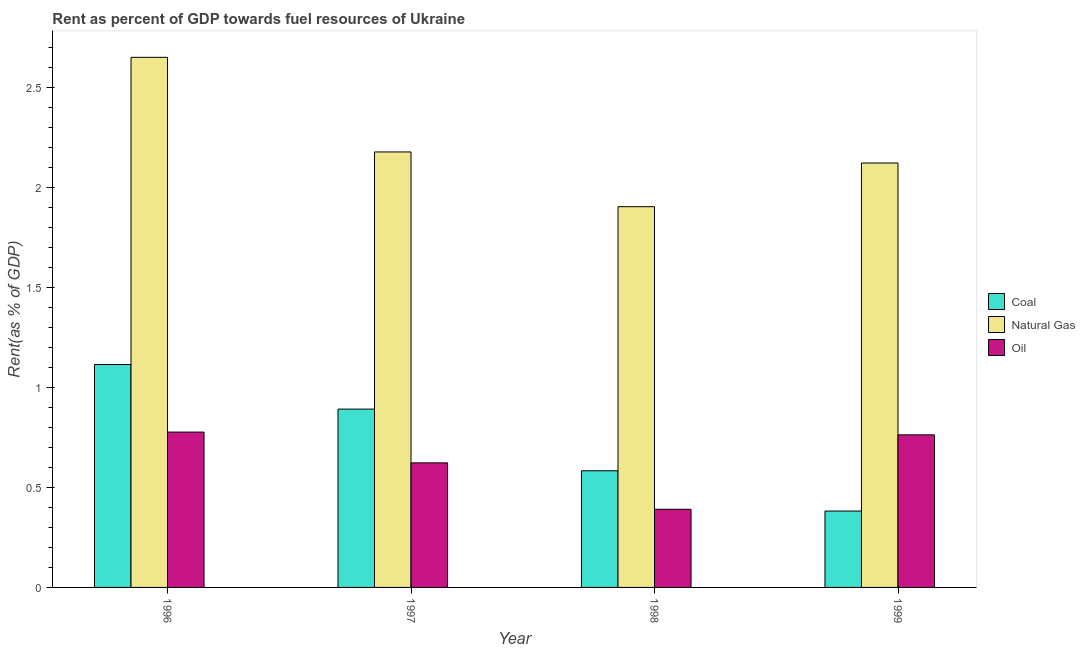Are the number of bars per tick equal to the number of legend labels?
Your answer should be very brief. Yes. How many bars are there on the 1st tick from the left?
Ensure brevity in your answer.  3. How many bars are there on the 2nd tick from the right?
Offer a terse response. 3. What is the rent towards natural gas in 1998?
Offer a terse response. 1.91. Across all years, what is the maximum rent towards oil?
Your response must be concise. 0.78. Across all years, what is the minimum rent towards natural gas?
Provide a succinct answer. 1.91. What is the total rent towards coal in the graph?
Your answer should be compact. 2.97. What is the difference between the rent towards natural gas in 1996 and that in 1999?
Provide a short and direct response. 0.53. What is the difference between the rent towards natural gas in 1997 and the rent towards coal in 1998?
Your answer should be very brief. 0.27. What is the average rent towards natural gas per year?
Offer a terse response. 2.22. In the year 1998, what is the difference between the rent towards coal and rent towards oil?
Ensure brevity in your answer.  0. In how many years, is the rent towards oil greater than 1 %?
Offer a very short reply. 0. What is the ratio of the rent towards coal in 1997 to that in 1998?
Keep it short and to the point. 1.53. Is the rent towards oil in 1997 less than that in 1998?
Provide a succinct answer. No. What is the difference between the highest and the second highest rent towards oil?
Offer a terse response. 0.01. What is the difference between the highest and the lowest rent towards oil?
Give a very brief answer. 0.39. What does the 2nd bar from the left in 1999 represents?
Provide a succinct answer. Natural Gas. What does the 1st bar from the right in 1998 represents?
Provide a succinct answer. Oil. How many bars are there?
Keep it short and to the point. 12. What is the difference between two consecutive major ticks on the Y-axis?
Provide a succinct answer. 0.5. Where does the legend appear in the graph?
Offer a very short reply. Center right. What is the title of the graph?
Your answer should be very brief. Rent as percent of GDP towards fuel resources of Ukraine. Does "Ages 20-50" appear as one of the legend labels in the graph?
Make the answer very short. No. What is the label or title of the Y-axis?
Provide a short and direct response. Rent(as % of GDP). What is the Rent(as % of GDP) of Coal in 1996?
Your response must be concise. 1.12. What is the Rent(as % of GDP) of Natural Gas in 1996?
Offer a terse response. 2.65. What is the Rent(as % of GDP) in Oil in 1996?
Ensure brevity in your answer.  0.78. What is the Rent(as % of GDP) of Coal in 1997?
Your answer should be very brief. 0.89. What is the Rent(as % of GDP) of Natural Gas in 1997?
Provide a short and direct response. 2.18. What is the Rent(as % of GDP) in Oil in 1997?
Provide a short and direct response. 0.62. What is the Rent(as % of GDP) in Coal in 1998?
Offer a terse response. 0.58. What is the Rent(as % of GDP) of Natural Gas in 1998?
Give a very brief answer. 1.91. What is the Rent(as % of GDP) in Oil in 1998?
Your answer should be compact. 0.39. What is the Rent(as % of GDP) in Coal in 1999?
Offer a very short reply. 0.38. What is the Rent(as % of GDP) in Natural Gas in 1999?
Your answer should be compact. 2.12. What is the Rent(as % of GDP) in Oil in 1999?
Your answer should be compact. 0.76. Across all years, what is the maximum Rent(as % of GDP) of Coal?
Your response must be concise. 1.12. Across all years, what is the maximum Rent(as % of GDP) in Natural Gas?
Provide a succinct answer. 2.65. Across all years, what is the maximum Rent(as % of GDP) in Oil?
Offer a very short reply. 0.78. Across all years, what is the minimum Rent(as % of GDP) of Coal?
Keep it short and to the point. 0.38. Across all years, what is the minimum Rent(as % of GDP) in Natural Gas?
Provide a succinct answer. 1.91. Across all years, what is the minimum Rent(as % of GDP) of Oil?
Ensure brevity in your answer.  0.39. What is the total Rent(as % of GDP) of Coal in the graph?
Offer a terse response. 2.97. What is the total Rent(as % of GDP) in Natural Gas in the graph?
Give a very brief answer. 8.86. What is the total Rent(as % of GDP) of Oil in the graph?
Ensure brevity in your answer.  2.56. What is the difference between the Rent(as % of GDP) of Coal in 1996 and that in 1997?
Give a very brief answer. 0.22. What is the difference between the Rent(as % of GDP) of Natural Gas in 1996 and that in 1997?
Your answer should be very brief. 0.47. What is the difference between the Rent(as % of GDP) in Oil in 1996 and that in 1997?
Make the answer very short. 0.15. What is the difference between the Rent(as % of GDP) of Coal in 1996 and that in 1998?
Your answer should be compact. 0.53. What is the difference between the Rent(as % of GDP) in Natural Gas in 1996 and that in 1998?
Ensure brevity in your answer.  0.75. What is the difference between the Rent(as % of GDP) of Oil in 1996 and that in 1998?
Make the answer very short. 0.39. What is the difference between the Rent(as % of GDP) in Coal in 1996 and that in 1999?
Give a very brief answer. 0.73. What is the difference between the Rent(as % of GDP) of Natural Gas in 1996 and that in 1999?
Make the answer very short. 0.53. What is the difference between the Rent(as % of GDP) of Oil in 1996 and that in 1999?
Your response must be concise. 0.01. What is the difference between the Rent(as % of GDP) of Coal in 1997 and that in 1998?
Your response must be concise. 0.31. What is the difference between the Rent(as % of GDP) of Natural Gas in 1997 and that in 1998?
Provide a short and direct response. 0.27. What is the difference between the Rent(as % of GDP) of Oil in 1997 and that in 1998?
Offer a terse response. 0.23. What is the difference between the Rent(as % of GDP) of Coal in 1997 and that in 1999?
Offer a terse response. 0.51. What is the difference between the Rent(as % of GDP) of Natural Gas in 1997 and that in 1999?
Make the answer very short. 0.06. What is the difference between the Rent(as % of GDP) of Oil in 1997 and that in 1999?
Make the answer very short. -0.14. What is the difference between the Rent(as % of GDP) in Coal in 1998 and that in 1999?
Your response must be concise. 0.2. What is the difference between the Rent(as % of GDP) of Natural Gas in 1998 and that in 1999?
Make the answer very short. -0.22. What is the difference between the Rent(as % of GDP) in Oil in 1998 and that in 1999?
Your response must be concise. -0.37. What is the difference between the Rent(as % of GDP) of Coal in 1996 and the Rent(as % of GDP) of Natural Gas in 1997?
Provide a succinct answer. -1.06. What is the difference between the Rent(as % of GDP) of Coal in 1996 and the Rent(as % of GDP) of Oil in 1997?
Ensure brevity in your answer.  0.49. What is the difference between the Rent(as % of GDP) of Natural Gas in 1996 and the Rent(as % of GDP) of Oil in 1997?
Provide a short and direct response. 2.03. What is the difference between the Rent(as % of GDP) in Coal in 1996 and the Rent(as % of GDP) in Natural Gas in 1998?
Ensure brevity in your answer.  -0.79. What is the difference between the Rent(as % of GDP) in Coal in 1996 and the Rent(as % of GDP) in Oil in 1998?
Keep it short and to the point. 0.72. What is the difference between the Rent(as % of GDP) of Natural Gas in 1996 and the Rent(as % of GDP) of Oil in 1998?
Your answer should be very brief. 2.26. What is the difference between the Rent(as % of GDP) of Coal in 1996 and the Rent(as % of GDP) of Natural Gas in 1999?
Offer a very short reply. -1.01. What is the difference between the Rent(as % of GDP) in Coal in 1996 and the Rent(as % of GDP) in Oil in 1999?
Offer a terse response. 0.35. What is the difference between the Rent(as % of GDP) in Natural Gas in 1996 and the Rent(as % of GDP) in Oil in 1999?
Ensure brevity in your answer.  1.89. What is the difference between the Rent(as % of GDP) in Coal in 1997 and the Rent(as % of GDP) in Natural Gas in 1998?
Your answer should be very brief. -1.01. What is the difference between the Rent(as % of GDP) of Coal in 1997 and the Rent(as % of GDP) of Oil in 1998?
Give a very brief answer. 0.5. What is the difference between the Rent(as % of GDP) in Natural Gas in 1997 and the Rent(as % of GDP) in Oil in 1998?
Make the answer very short. 1.79. What is the difference between the Rent(as % of GDP) of Coal in 1997 and the Rent(as % of GDP) of Natural Gas in 1999?
Ensure brevity in your answer.  -1.23. What is the difference between the Rent(as % of GDP) of Coal in 1997 and the Rent(as % of GDP) of Oil in 1999?
Provide a short and direct response. 0.13. What is the difference between the Rent(as % of GDP) in Natural Gas in 1997 and the Rent(as % of GDP) in Oil in 1999?
Provide a short and direct response. 1.42. What is the difference between the Rent(as % of GDP) in Coal in 1998 and the Rent(as % of GDP) in Natural Gas in 1999?
Your answer should be very brief. -1.54. What is the difference between the Rent(as % of GDP) in Coal in 1998 and the Rent(as % of GDP) in Oil in 1999?
Your answer should be compact. -0.18. What is the difference between the Rent(as % of GDP) in Natural Gas in 1998 and the Rent(as % of GDP) in Oil in 1999?
Ensure brevity in your answer.  1.14. What is the average Rent(as % of GDP) in Coal per year?
Offer a very short reply. 0.74. What is the average Rent(as % of GDP) in Natural Gas per year?
Provide a short and direct response. 2.22. What is the average Rent(as % of GDP) in Oil per year?
Your answer should be compact. 0.64. In the year 1996, what is the difference between the Rent(as % of GDP) in Coal and Rent(as % of GDP) in Natural Gas?
Offer a terse response. -1.54. In the year 1996, what is the difference between the Rent(as % of GDP) in Coal and Rent(as % of GDP) in Oil?
Give a very brief answer. 0.34. In the year 1996, what is the difference between the Rent(as % of GDP) in Natural Gas and Rent(as % of GDP) in Oil?
Provide a succinct answer. 1.88. In the year 1997, what is the difference between the Rent(as % of GDP) in Coal and Rent(as % of GDP) in Natural Gas?
Keep it short and to the point. -1.29. In the year 1997, what is the difference between the Rent(as % of GDP) of Coal and Rent(as % of GDP) of Oil?
Offer a terse response. 0.27. In the year 1997, what is the difference between the Rent(as % of GDP) in Natural Gas and Rent(as % of GDP) in Oil?
Provide a succinct answer. 1.56. In the year 1998, what is the difference between the Rent(as % of GDP) in Coal and Rent(as % of GDP) in Natural Gas?
Your answer should be compact. -1.32. In the year 1998, what is the difference between the Rent(as % of GDP) in Coal and Rent(as % of GDP) in Oil?
Keep it short and to the point. 0.19. In the year 1998, what is the difference between the Rent(as % of GDP) of Natural Gas and Rent(as % of GDP) of Oil?
Offer a very short reply. 1.51. In the year 1999, what is the difference between the Rent(as % of GDP) of Coal and Rent(as % of GDP) of Natural Gas?
Your answer should be compact. -1.74. In the year 1999, what is the difference between the Rent(as % of GDP) of Coal and Rent(as % of GDP) of Oil?
Ensure brevity in your answer.  -0.38. In the year 1999, what is the difference between the Rent(as % of GDP) of Natural Gas and Rent(as % of GDP) of Oil?
Your response must be concise. 1.36. What is the ratio of the Rent(as % of GDP) of Natural Gas in 1996 to that in 1997?
Offer a very short reply. 1.22. What is the ratio of the Rent(as % of GDP) of Oil in 1996 to that in 1997?
Your answer should be very brief. 1.25. What is the ratio of the Rent(as % of GDP) in Coal in 1996 to that in 1998?
Your response must be concise. 1.91. What is the ratio of the Rent(as % of GDP) in Natural Gas in 1996 to that in 1998?
Your answer should be very brief. 1.39. What is the ratio of the Rent(as % of GDP) of Oil in 1996 to that in 1998?
Offer a very short reply. 1.99. What is the ratio of the Rent(as % of GDP) in Coal in 1996 to that in 1999?
Keep it short and to the point. 2.92. What is the ratio of the Rent(as % of GDP) in Natural Gas in 1996 to that in 1999?
Provide a short and direct response. 1.25. What is the ratio of the Rent(as % of GDP) of Oil in 1996 to that in 1999?
Provide a short and direct response. 1.02. What is the ratio of the Rent(as % of GDP) in Coal in 1997 to that in 1998?
Ensure brevity in your answer.  1.53. What is the ratio of the Rent(as % of GDP) of Natural Gas in 1997 to that in 1998?
Provide a short and direct response. 1.14. What is the ratio of the Rent(as % of GDP) of Oil in 1997 to that in 1998?
Ensure brevity in your answer.  1.59. What is the ratio of the Rent(as % of GDP) in Coal in 1997 to that in 1999?
Offer a terse response. 2.33. What is the ratio of the Rent(as % of GDP) in Oil in 1997 to that in 1999?
Give a very brief answer. 0.82. What is the ratio of the Rent(as % of GDP) of Coal in 1998 to that in 1999?
Make the answer very short. 1.53. What is the ratio of the Rent(as % of GDP) in Natural Gas in 1998 to that in 1999?
Provide a succinct answer. 0.9. What is the ratio of the Rent(as % of GDP) in Oil in 1998 to that in 1999?
Offer a terse response. 0.51. What is the difference between the highest and the second highest Rent(as % of GDP) of Coal?
Offer a very short reply. 0.22. What is the difference between the highest and the second highest Rent(as % of GDP) in Natural Gas?
Give a very brief answer. 0.47. What is the difference between the highest and the second highest Rent(as % of GDP) of Oil?
Offer a terse response. 0.01. What is the difference between the highest and the lowest Rent(as % of GDP) of Coal?
Keep it short and to the point. 0.73. What is the difference between the highest and the lowest Rent(as % of GDP) in Natural Gas?
Make the answer very short. 0.75. What is the difference between the highest and the lowest Rent(as % of GDP) of Oil?
Your response must be concise. 0.39. 